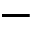<formula> <loc_0><loc_0><loc_500><loc_500>-</formula> 